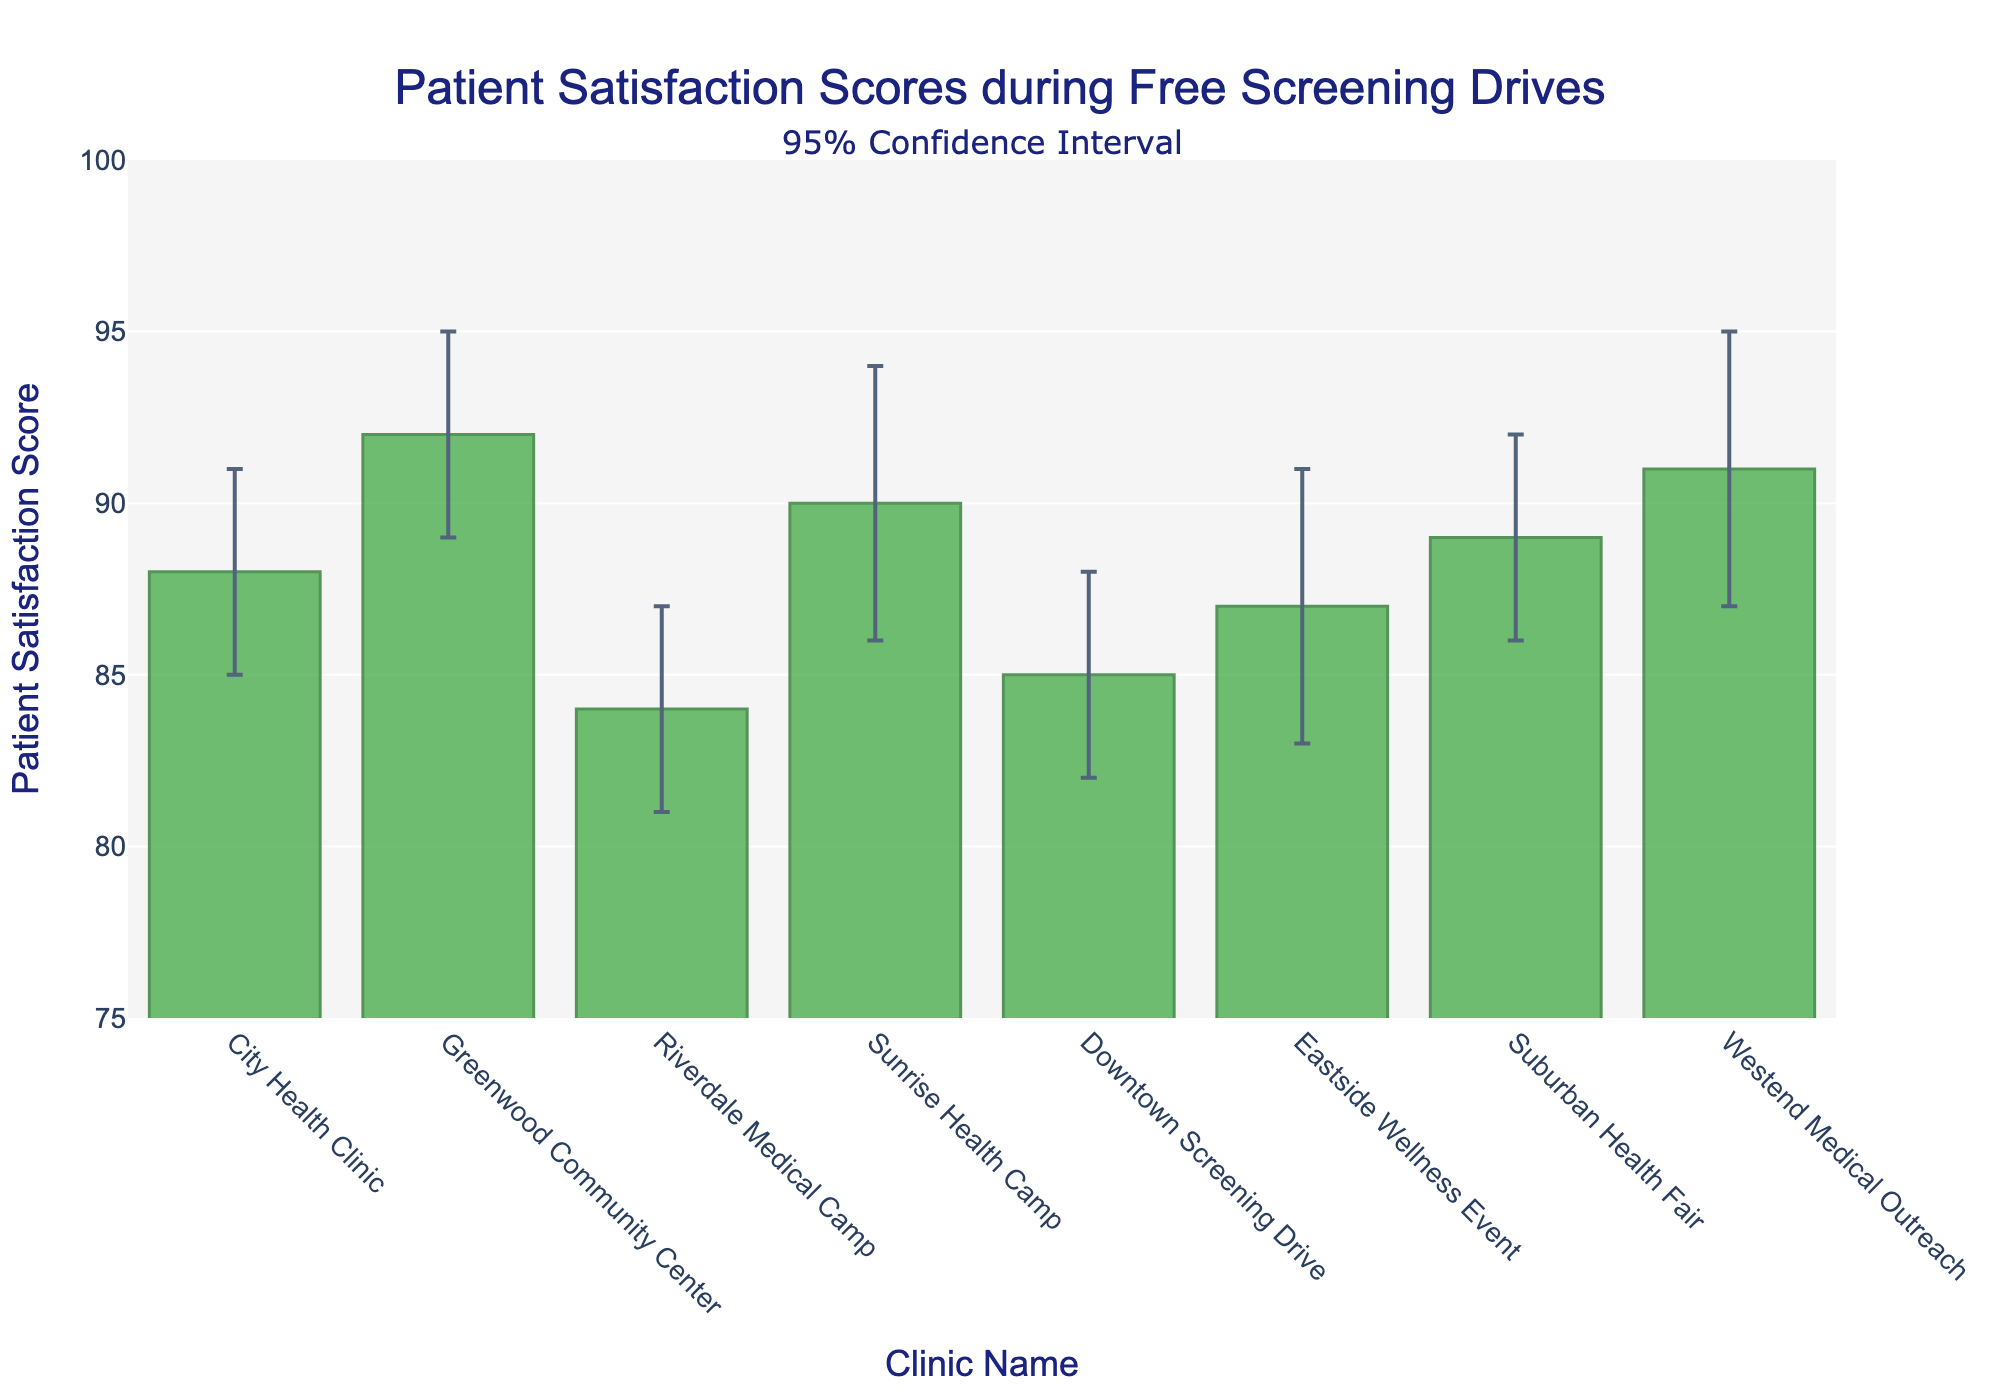Which clinic has the highest patient satisfaction score? The highest patient satisfaction score, which is 92, is from the Greenwood Community Center.
Answer: Greenwood Community Center What is the patient satisfaction score at Sunrise Health Camp? The bar corresponding to Sunrise Health Camp shows a patient satisfaction score of 90.
Answer: 90 What is the range (difference between the upper and lower bounds) of patient satisfaction scores at Downtown Screening Drive? The lower and upper bounds for Downtown Screening Drive are 82 and 88, respectively. The range is calculated as 88 - 82 = 6.
Answer: 6 How much higher is the patient satisfaction score of Westend Medical Outreach compared to Riverdale Medical Camp? The score for Westend Medical Outreach is 91, and for Riverdale Medical Camp it is 84. The difference is 91 - 84 = 7.
Answer: 7 Which clinic has the widest confidence interval? By comparing the lengths of the error bars, Westend Medical Outreach has the widest confidence interval ranging from 87 to 95, which is a difference of 8 points.
Answer: Westend Medical Outreach How many clinics scored above 88 in patient satisfaction? The clinics with scores above 88 are Greenwood Community Center (92), Sunrise Health Camp (90), and Westend Medical Outreach (91), so there are 3 clinics.
Answer: 3 What is the median patient satisfaction score of the clinics? The scores in ascending order are 84, 85, 87, 88, 89, 90, 91, 92. With 8 clinics, the median is the average of the 4th and 5th scores: (88 + 89)/2 = 88.5.
Answer: 88.5 Which clinic has the lowest lower bound in the confidence interval? The lowest lower bound is 81, which corresponds to Riverdale Medical Camp.
Answer: Riverdale Medical Camp What is the overall mean patient satisfaction score for all clinics? The sum of the scores is 88 (City Health Clinic) + 92 (Greenwood Community Center) + 84 (Riverdale Medical Camp) + 90 (Sunrise Health Camp) + 85 (Downtown Screening Drive) + 87 (Eastside Wellness Event) + 89 (Suburban Health Fair) + 91 (Westend Medical Outreach) = 706. The mean is 706 / 8 = 88.25.
Answer: 88.25 